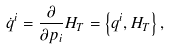Convert formula to latex. <formula><loc_0><loc_0><loc_500><loc_500>\dot { q } ^ { i } = \frac { \partial } { \partial p _ { i } } H _ { T } = \left \{ q ^ { i } , H _ { T } \right \} ,</formula> 